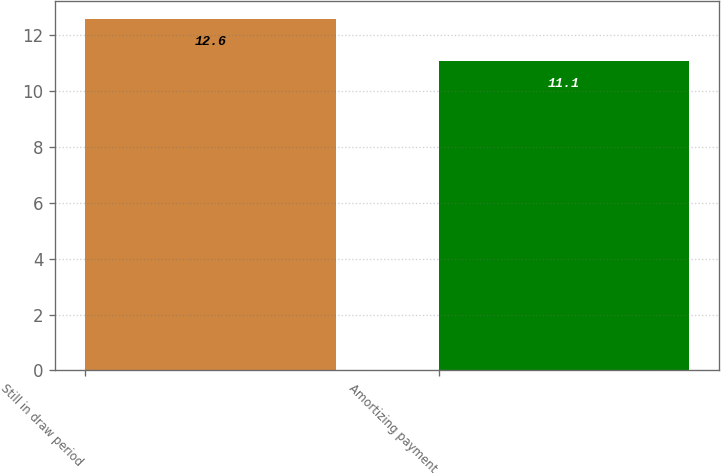Convert chart. <chart><loc_0><loc_0><loc_500><loc_500><bar_chart><fcel>Still in draw period<fcel>Amortizing payment<nl><fcel>12.6<fcel>11.1<nl></chart> 